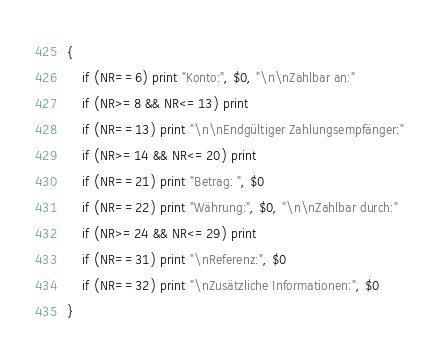Convert code to text. <code><loc_0><loc_0><loc_500><loc_500><_Awk_>{
    if (NR==6) print "Konto:", $0, "\n\nZahlbar an:"
    if (NR>=8 && NR<=13) print
    if (NR==13) print "\n\nEndgültiger Zahlungsempfänger:"
    if (NR>=14 && NR<=20) print
    if (NR==21) print "Betrag: ", $0
    if (NR==22) print "Währung:", $0, "\n\nZahlbar durch:"
    if (NR>=24 && NR<=29) print
    if (NR==31) print "\nReferenz:", $0
    if (NR==32) print "\nZusätzliche Informationen:", $0
}
</code> 